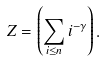<formula> <loc_0><loc_0><loc_500><loc_500>Z = \left ( \sum _ { i \leq n } i ^ { - \gamma } \right ) .</formula> 